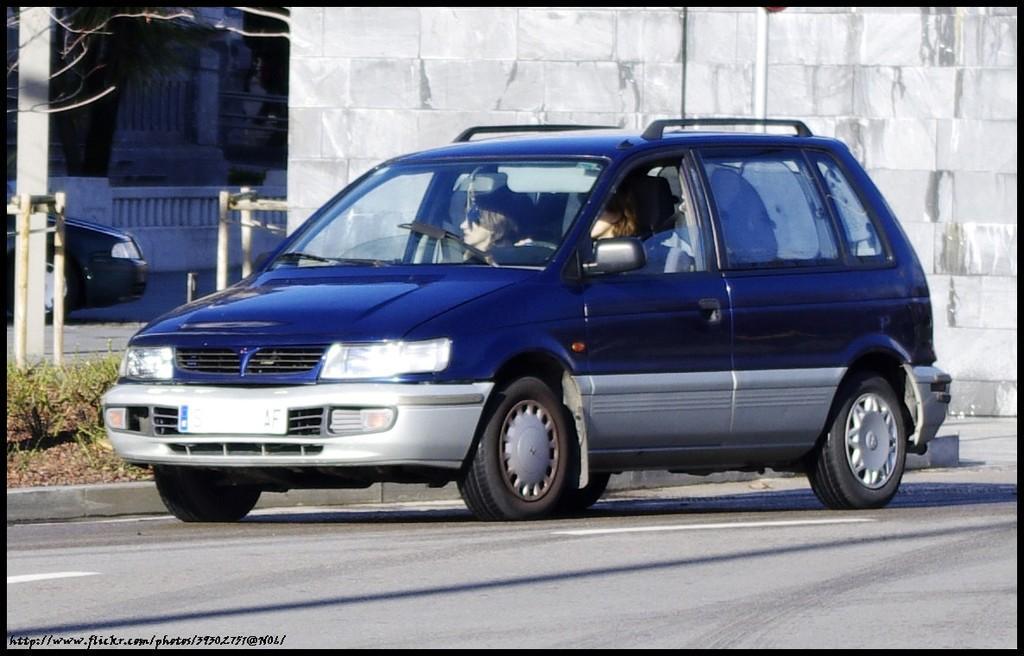Could you give a brief overview of what you see in this image? In this image we can see two persons are riding in a car on the road. In the background we can see a vehicle, wall, railing, plants, branches of a tree, poles and objects. 